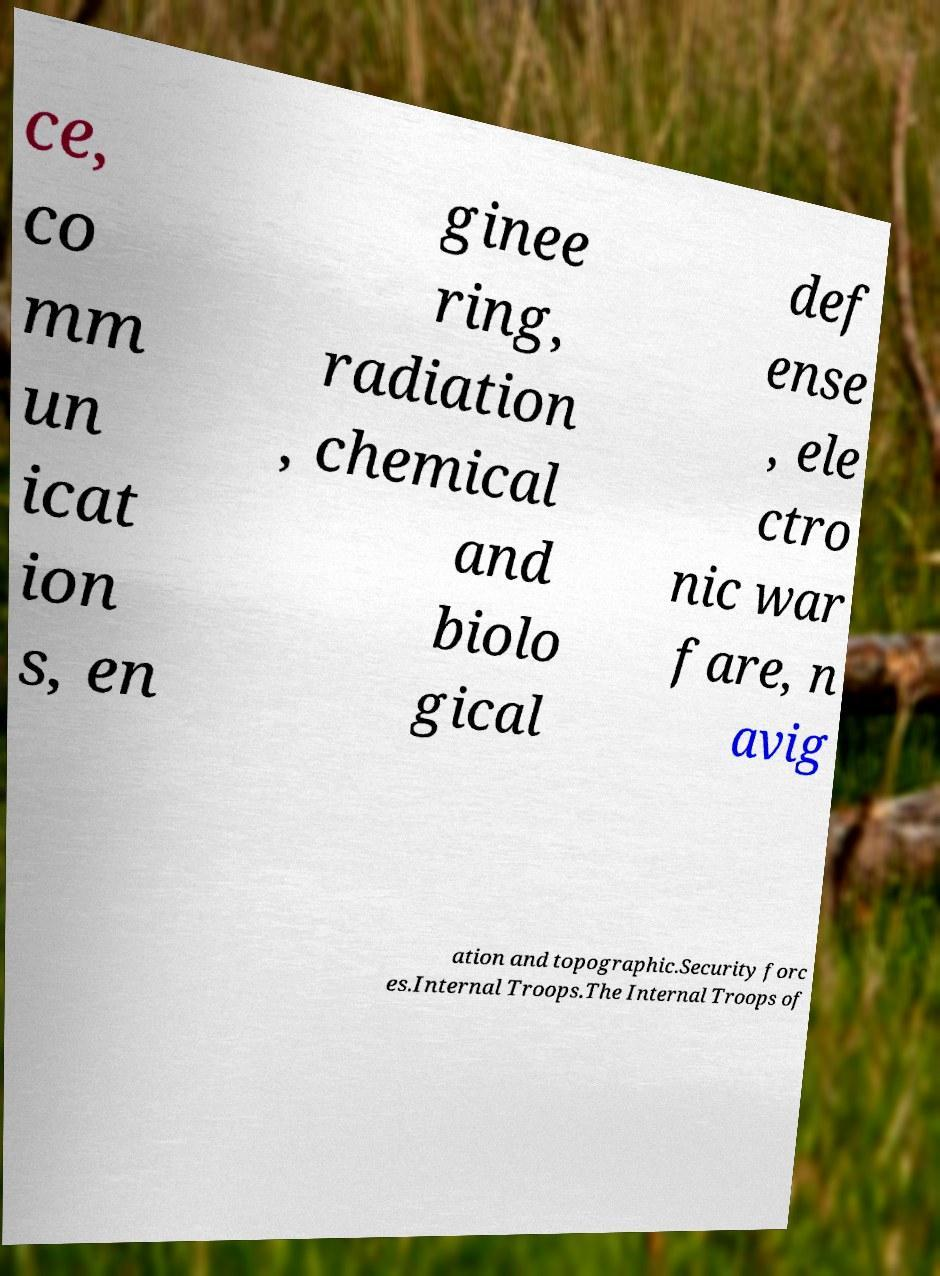What messages or text are displayed in this image? I need them in a readable, typed format. ce, co mm un icat ion s, en ginee ring, radiation , chemical and biolo gical def ense , ele ctro nic war fare, n avig ation and topographic.Security forc es.Internal Troops.The Internal Troops of 